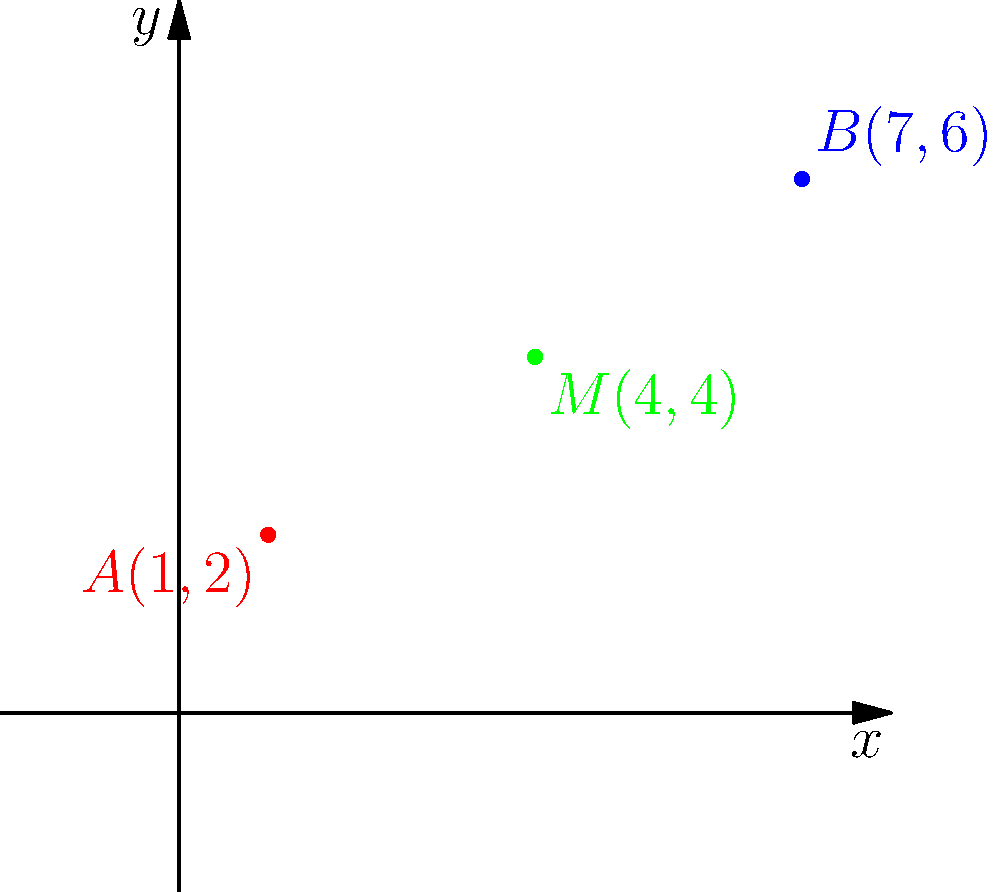Two households in need of resources are located at points $A(1,2)$ and $B(7,6)$ on a coordinate plane. To optimally serve both households, you need to place a community resource center at the midpoint between these two locations. Calculate the coordinates of the midpoint $M$ where the resource center should be placed. To find the midpoint $M(x,y)$ between two points $A(x_1,y_1)$ and $B(x_2,y_2)$, we use the midpoint formula:

$$x = \frac{x_1 + x_2}{2}$$
$$y = \frac{y_1 + y_2}{2}$$

Given:
$A(1,2)$ and $B(7,6)$

Step 1: Calculate the x-coordinate of the midpoint:
$$x = \frac{x_1 + x_2}{2} = \frac{1 + 7}{2} = \frac{8}{2} = 4$$

Step 2: Calculate the y-coordinate of the midpoint:
$$y = \frac{y_1 + y_2}{2} = \frac{2 + 6}{2} = \frac{8}{2} = 4$$

Therefore, the midpoint $M$ has coordinates $(4,4)$.
Answer: $M(4,4)$ 